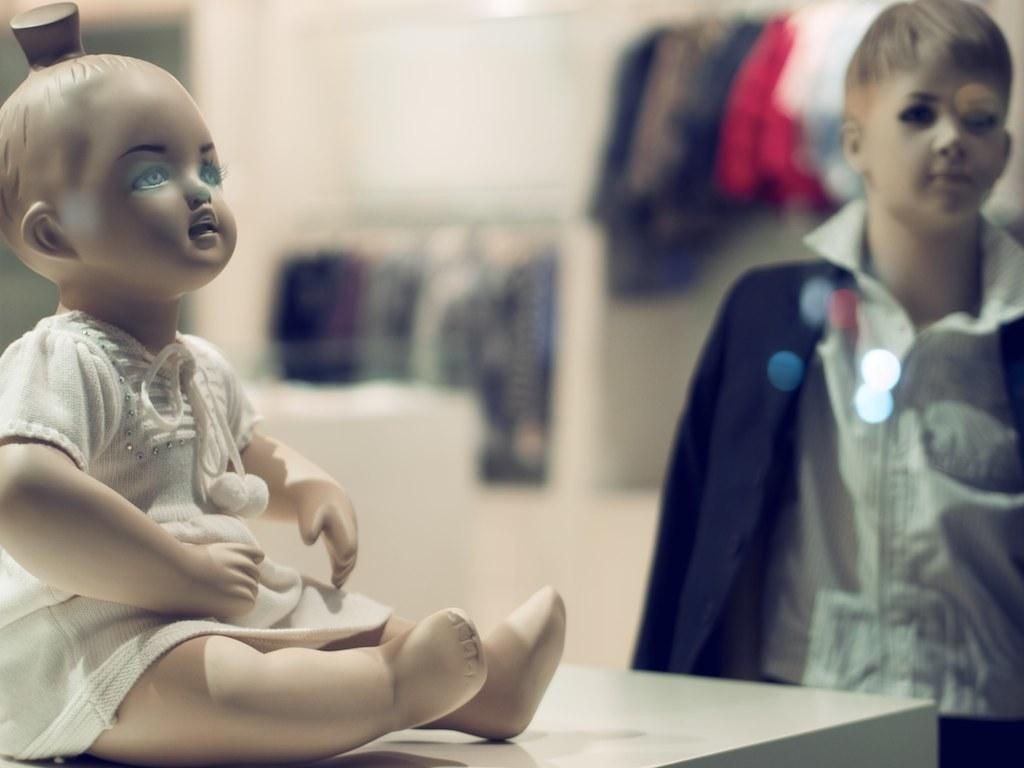What type of object can be seen in the image? There is a doll in the image. What other object is present in the image? There is a mannequin in the image. What can be found on or around the doll and mannequin? There are clothes in the image. What type of lace can be seen on the hill in the image? There is no hill or lace present in the image. What type of meeting is taking place in the image? There is no meeting depicted in the image. 